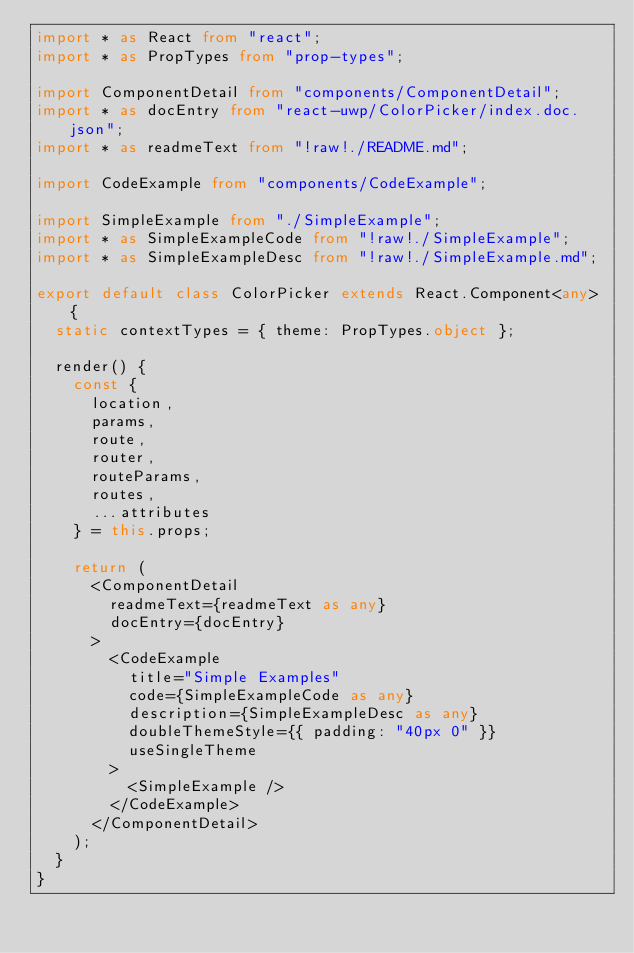<code> <loc_0><loc_0><loc_500><loc_500><_TypeScript_>import * as React from "react";
import * as PropTypes from "prop-types";

import ComponentDetail from "components/ComponentDetail";
import * as docEntry from "react-uwp/ColorPicker/index.doc.json";
import * as readmeText from "!raw!./README.md";

import CodeExample from "components/CodeExample";

import SimpleExample from "./SimpleExample";
import * as SimpleExampleCode from "!raw!./SimpleExample";
import * as SimpleExampleDesc from "!raw!./SimpleExample.md";

export default class ColorPicker extends React.Component<any> {
  static contextTypes = { theme: PropTypes.object };

  render() {
    const {
      location,
      params,
      route,
      router,
      routeParams,
      routes,
      ...attributes
    } = this.props;

    return (
      <ComponentDetail
        readmeText={readmeText as any}
        docEntry={docEntry}
      >
        <CodeExample
          title="Simple Examples"
          code={SimpleExampleCode as any}
          description={SimpleExampleDesc as any}
          doubleThemeStyle={{ padding: "40px 0" }}
          useSingleTheme
        >
          <SimpleExample />
        </CodeExample>
      </ComponentDetail>
    );
  }
}
</code> 